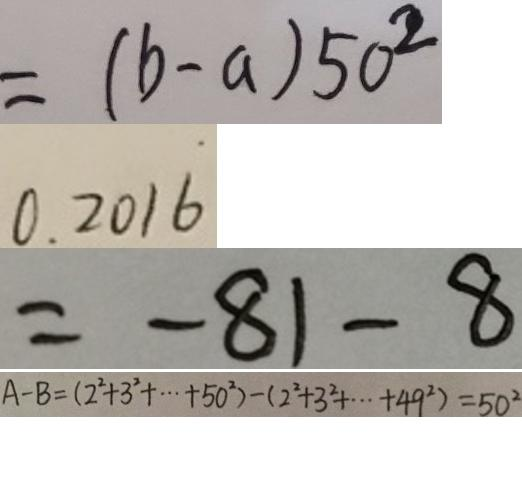Convert formula to latex. <formula><loc_0><loc_0><loc_500><loc_500>= ( b - a ) 5 0 ^ { 2 } 
 0 . 2 0 1 \dot { 6 } 
 = - 8 1 - 8 
 A - B = ( 2 ^ { 2 } + 3 ^ { 2 } + \cdots 5 0 ^ { 2 } ) - ( 2 ^ { 2 } + 3 ^ { 2 } + \cdots 4 9 ^ { 2 } ) = 5 0 ^ { 2 }</formula> 